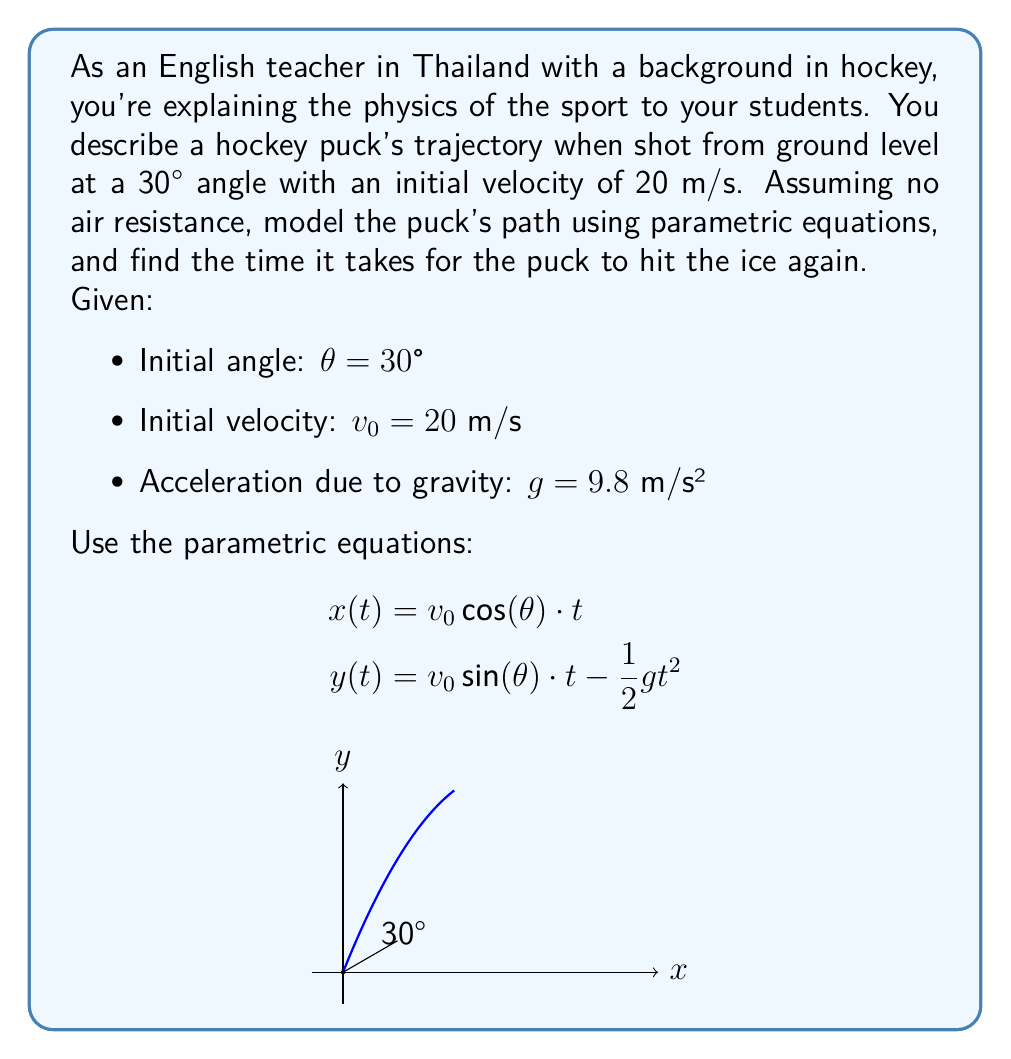Provide a solution to this math problem. Let's approach this step-by-step:

1) First, we need to calculate the components of the initial velocity:
   $v_x = v_0 \cos(\theta) = 20 \cos(30°) = 20 \cdot \frac{\sqrt{3}}{2} = 10\sqrt{3}$ m/s
   $v_y = v_0 \sin(\theta) = 20 \sin(30°) = 20 \cdot \frac{1}{2} = 10$ m/s

2) Now, we can write our parametric equations:
   $$x(t) = 10\sqrt{3}t$$
   $$y(t) = 10t - 4.9t^2$$

3) To find when the puck hits the ice again, we need to solve $y(t) = 0$:
   $0 = 10t - 4.9t^2$
   $4.9t^2 - 10t = 0$
   $t(4.9t - 10) = 0$

4) Solving this equation:
   $t = 0$ (initial position) or $4.9t - 10 = 0$
   $4.9t = 10$
   $t = \frac{10}{4.9} \approx 2.04$ seconds

5) We take the positive, non-zero solution as our answer.
Answer: $t \approx 2.04$ seconds 